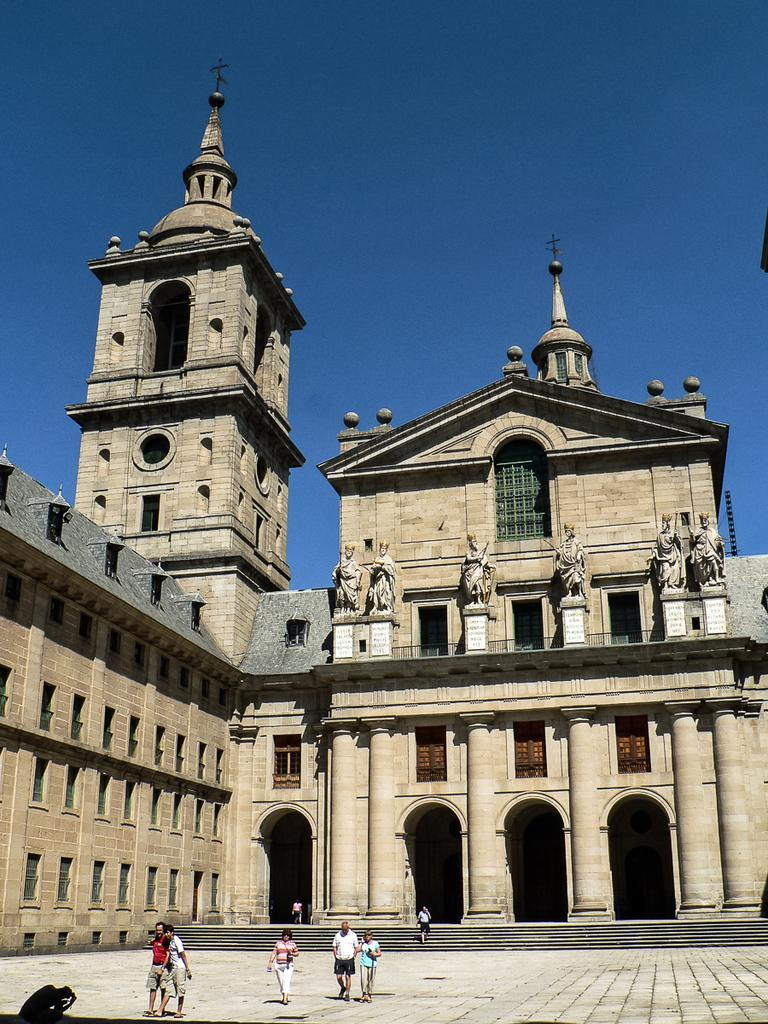What type of structure is present in the image? There is a building in the image. Who or what else can be seen in the image? There are people and statues in the image. What is the surface beneath the people and statues? The ground is visible in the image. Are there any architectural features in the image? Yes, there are stairs in the image. What is visible in the background of the image? The sky is visible in the image. What type of locket is being worn by the statue in the image? There are no lockets visible on any of the statues in the image. What knowledge is being shared among the people in the image? The image does not provide any information about the knowledge being shared among the people. 